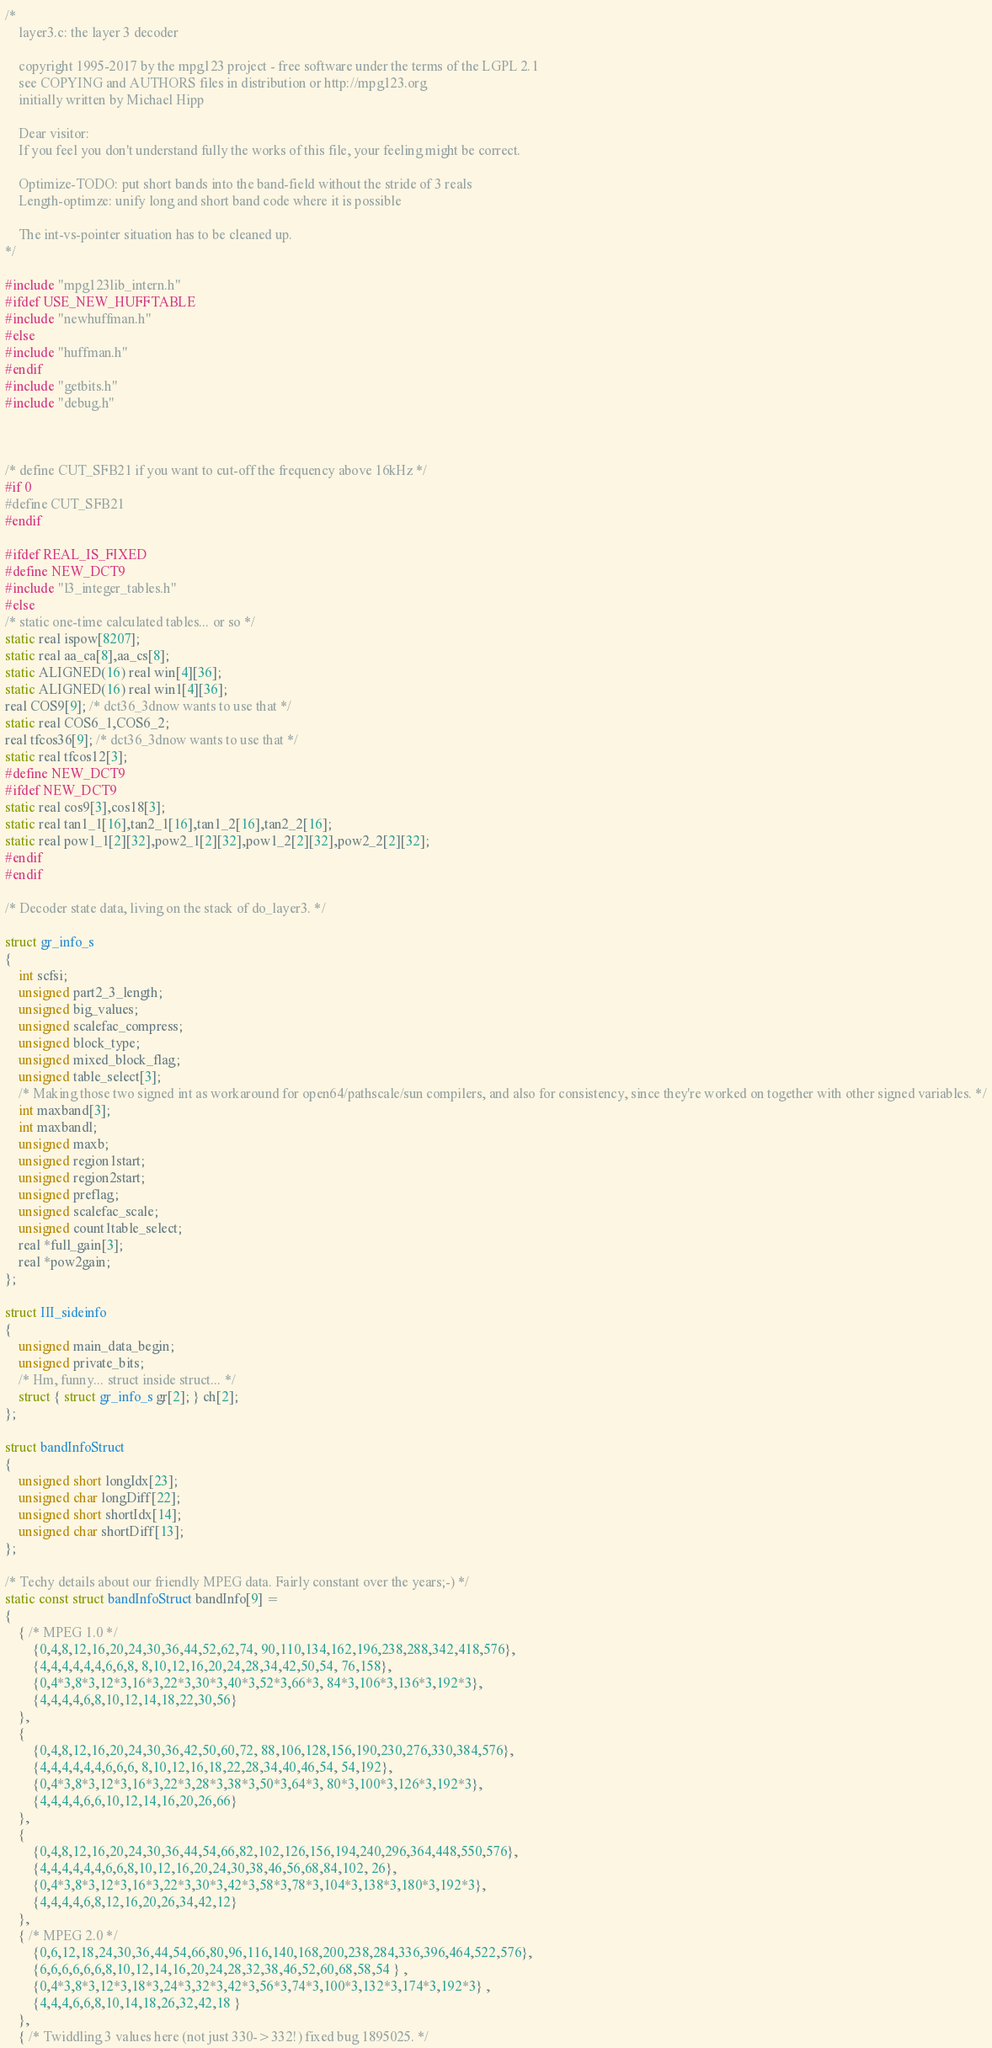Convert code to text. <code><loc_0><loc_0><loc_500><loc_500><_C_>/*
	layer3.c: the layer 3 decoder

	copyright 1995-2017 by the mpg123 project - free software under the terms of the LGPL 2.1
	see COPYING and AUTHORS files in distribution or http://mpg123.org
	initially written by Michael Hipp

	Dear visitor:
	If you feel you don't understand fully the works of this file, your feeling might be correct.

	Optimize-TODO: put short bands into the band-field without the stride of 3 reals
	Length-optimze: unify long and short band code where it is possible

	The int-vs-pointer situation has to be cleaned up.
*/

#include "mpg123lib_intern.h"
#ifdef USE_NEW_HUFFTABLE
#include "newhuffman.h"
#else
#include "huffman.h"
#endif
#include "getbits.h"
#include "debug.h"



/* define CUT_SFB21 if you want to cut-off the frequency above 16kHz */
#if 0
#define CUT_SFB21
#endif

#ifdef REAL_IS_FIXED
#define NEW_DCT9
#include "l3_integer_tables.h"
#else
/* static one-time calculated tables... or so */
static real ispow[8207];
static real aa_ca[8],aa_cs[8];
static ALIGNED(16) real win[4][36];
static ALIGNED(16) real win1[4][36];
real COS9[9]; /* dct36_3dnow wants to use that */
static real COS6_1,COS6_2;
real tfcos36[9]; /* dct36_3dnow wants to use that */
static real tfcos12[3];
#define NEW_DCT9
#ifdef NEW_DCT9
static real cos9[3],cos18[3];
static real tan1_1[16],tan2_1[16],tan1_2[16],tan2_2[16];
static real pow1_1[2][32],pow2_1[2][32],pow1_2[2][32],pow2_2[2][32];
#endif
#endif

/* Decoder state data, living on the stack of do_layer3. */

struct gr_info_s
{
	int scfsi;
	unsigned part2_3_length;
	unsigned big_values;
	unsigned scalefac_compress;
	unsigned block_type;
	unsigned mixed_block_flag;
	unsigned table_select[3];
	/* Making those two signed int as workaround for open64/pathscale/sun compilers, and also for consistency, since they're worked on together with other signed variables. */
	int maxband[3];
	int maxbandl;
	unsigned maxb;
	unsigned region1start;
	unsigned region2start;
	unsigned preflag;
	unsigned scalefac_scale;
	unsigned count1table_select;
	real *full_gain[3];
	real *pow2gain;
};

struct III_sideinfo
{
	unsigned main_data_begin;
	unsigned private_bits;
	/* Hm, funny... struct inside struct... */
	struct { struct gr_info_s gr[2]; } ch[2];
};

struct bandInfoStruct
{
	unsigned short longIdx[23];
	unsigned char longDiff[22];
	unsigned short shortIdx[14];
	unsigned char shortDiff[13];
};

/* Techy details about our friendly MPEG data. Fairly constant over the years;-) */
static const struct bandInfoStruct bandInfo[9] =
{
	{ /* MPEG 1.0 */
		{0,4,8,12,16,20,24,30,36,44,52,62,74, 90,110,134,162,196,238,288,342,418,576},
		{4,4,4,4,4,4,6,6,8, 8,10,12,16,20,24,28,34,42,50,54, 76,158},
		{0,4*3,8*3,12*3,16*3,22*3,30*3,40*3,52*3,66*3, 84*3,106*3,136*3,192*3},
		{4,4,4,4,6,8,10,12,14,18,22,30,56}
	},
	{
		{0,4,8,12,16,20,24,30,36,42,50,60,72, 88,106,128,156,190,230,276,330,384,576},
		{4,4,4,4,4,4,6,6,6, 8,10,12,16,18,22,28,34,40,46,54, 54,192},
		{0,4*3,8*3,12*3,16*3,22*3,28*3,38*3,50*3,64*3, 80*3,100*3,126*3,192*3},
		{4,4,4,4,6,6,10,12,14,16,20,26,66}
	},
	{
		{0,4,8,12,16,20,24,30,36,44,54,66,82,102,126,156,194,240,296,364,448,550,576},
		{4,4,4,4,4,4,6,6,8,10,12,16,20,24,30,38,46,56,68,84,102, 26},
		{0,4*3,8*3,12*3,16*3,22*3,30*3,42*3,58*3,78*3,104*3,138*3,180*3,192*3},
		{4,4,4,4,6,8,12,16,20,26,34,42,12}
	},
	{ /* MPEG 2.0 */
		{0,6,12,18,24,30,36,44,54,66,80,96,116,140,168,200,238,284,336,396,464,522,576},
		{6,6,6,6,6,6,8,10,12,14,16,20,24,28,32,38,46,52,60,68,58,54 } ,
		{0,4*3,8*3,12*3,18*3,24*3,32*3,42*3,56*3,74*3,100*3,132*3,174*3,192*3} ,
		{4,4,4,6,6,8,10,14,18,26,32,42,18 }
	},
	{ /* Twiddling 3 values here (not just 330->332!) fixed bug 1895025. */</code> 